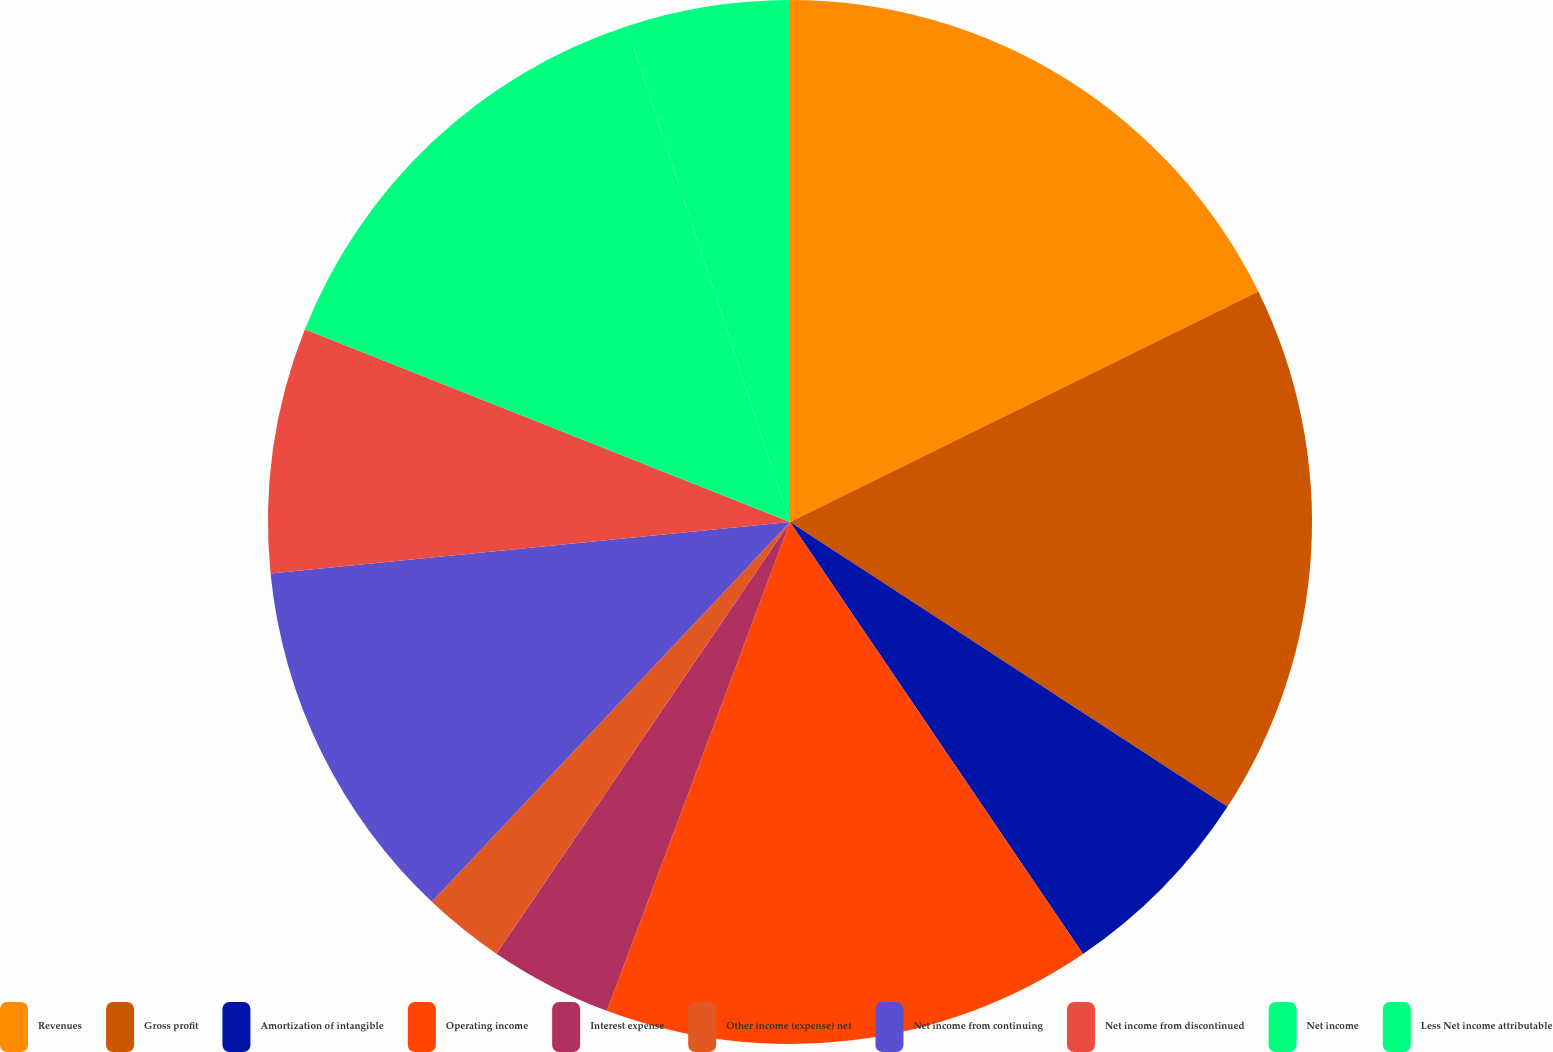Convert chart to OTSL. <chart><loc_0><loc_0><loc_500><loc_500><pie_chart><fcel>Revenues<fcel>Gross profit<fcel>Amortization of intangible<fcel>Operating income<fcel>Interest expense<fcel>Other income (expense) net<fcel>Net income from continuing<fcel>Net income from discontinued<fcel>Net income<fcel>Less Net income attributable<nl><fcel>17.72%<fcel>16.46%<fcel>6.33%<fcel>15.19%<fcel>3.8%<fcel>2.53%<fcel>11.39%<fcel>7.59%<fcel>13.92%<fcel>5.06%<nl></chart> 